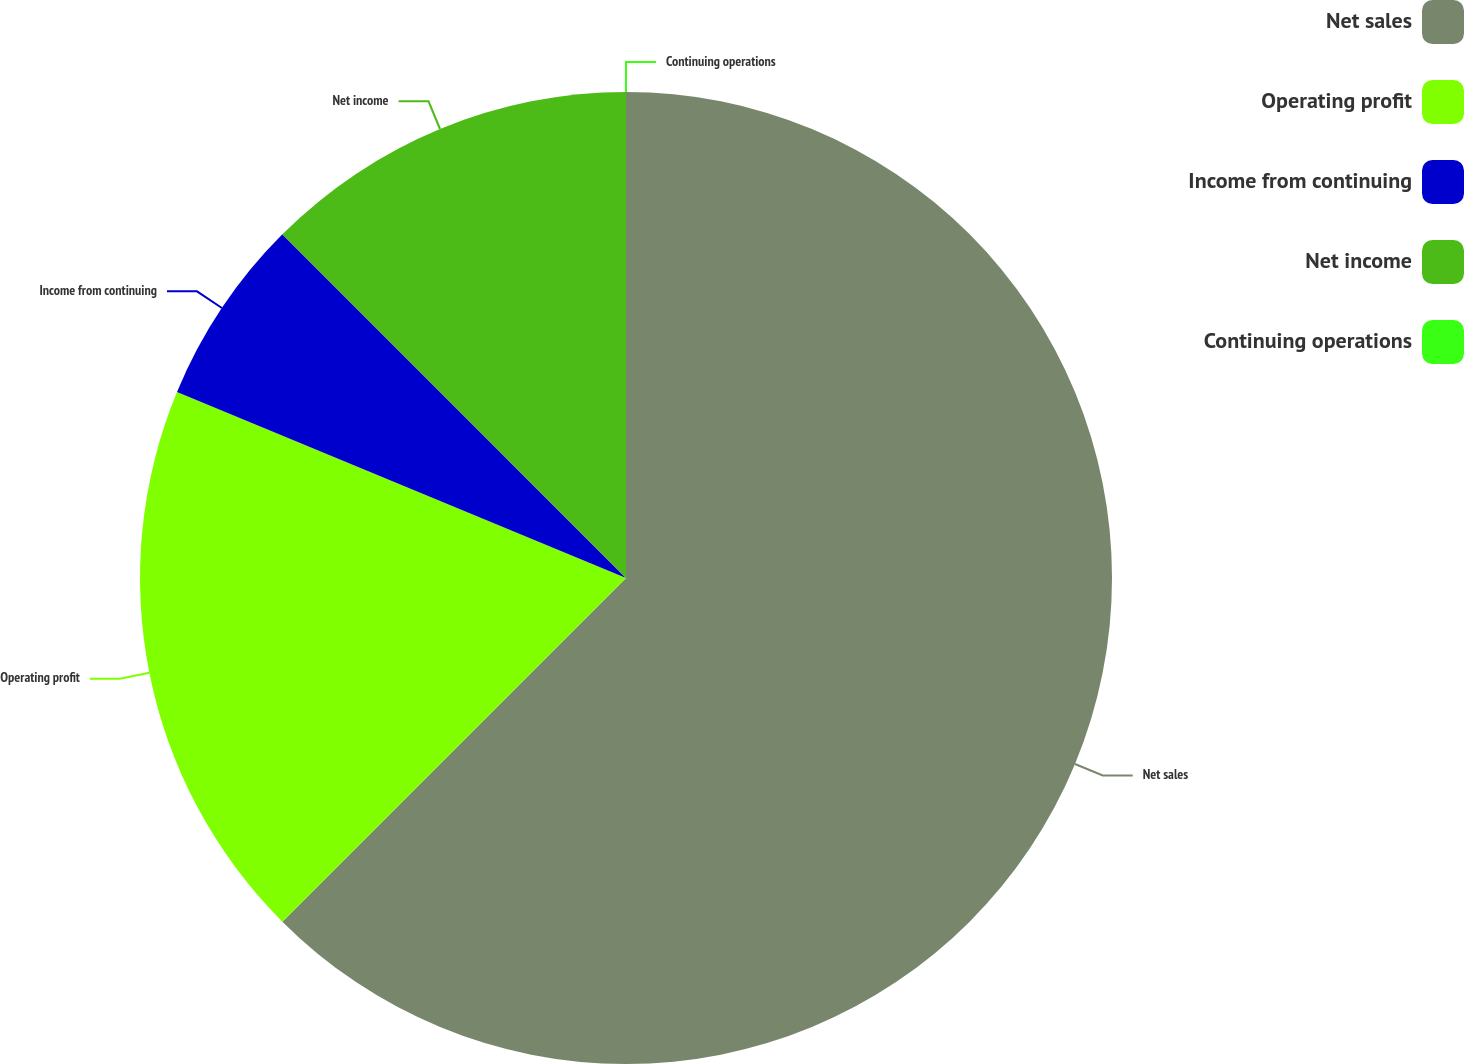<chart> <loc_0><loc_0><loc_500><loc_500><pie_chart><fcel>Net sales<fcel>Operating profit<fcel>Income from continuing<fcel>Net income<fcel>Continuing operations<nl><fcel>62.5%<fcel>18.75%<fcel>6.25%<fcel>12.5%<fcel>0.0%<nl></chart> 